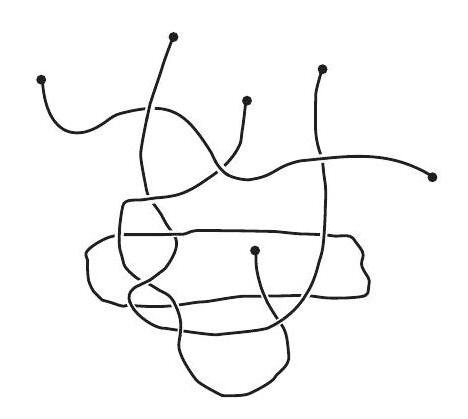How many pieces of string are there in the picture?
 Answer is 4. 